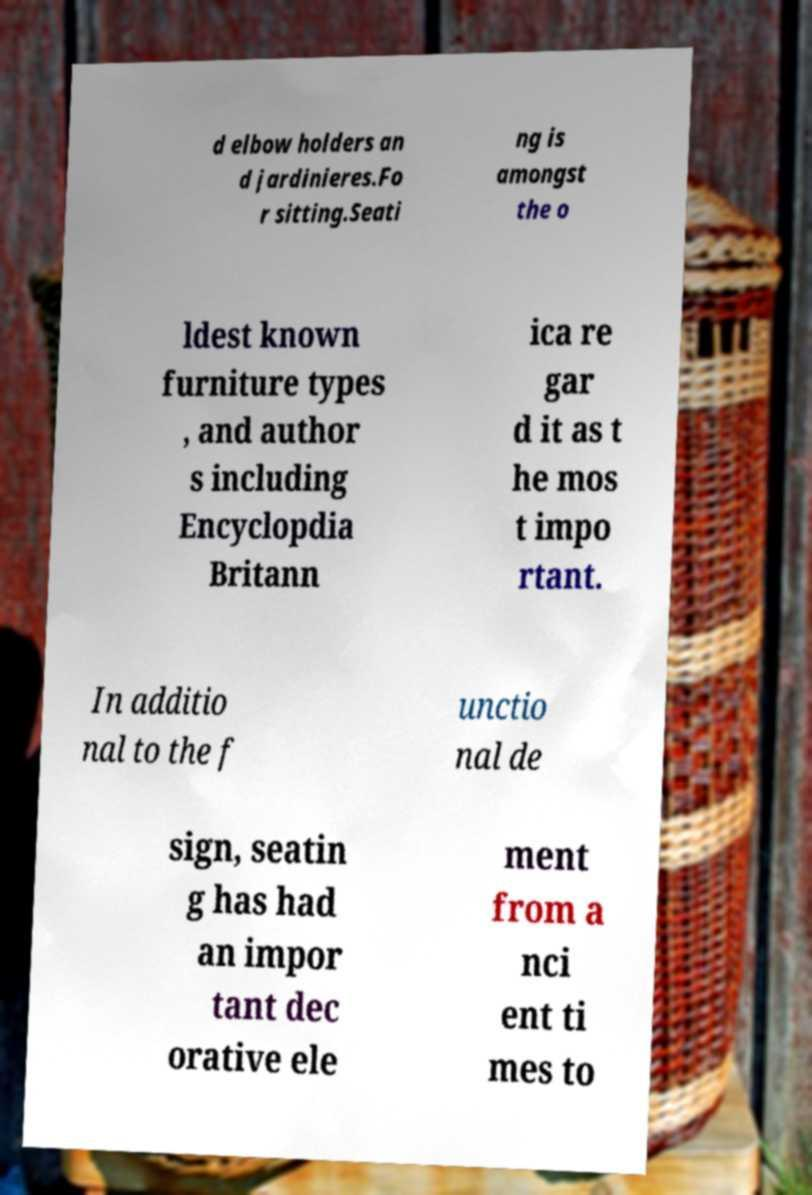For documentation purposes, I need the text within this image transcribed. Could you provide that? d elbow holders an d jardinieres.Fo r sitting.Seati ng is amongst the o ldest known furniture types , and author s including Encyclopdia Britann ica re gar d it as t he mos t impo rtant. In additio nal to the f unctio nal de sign, seatin g has had an impor tant dec orative ele ment from a nci ent ti mes to 